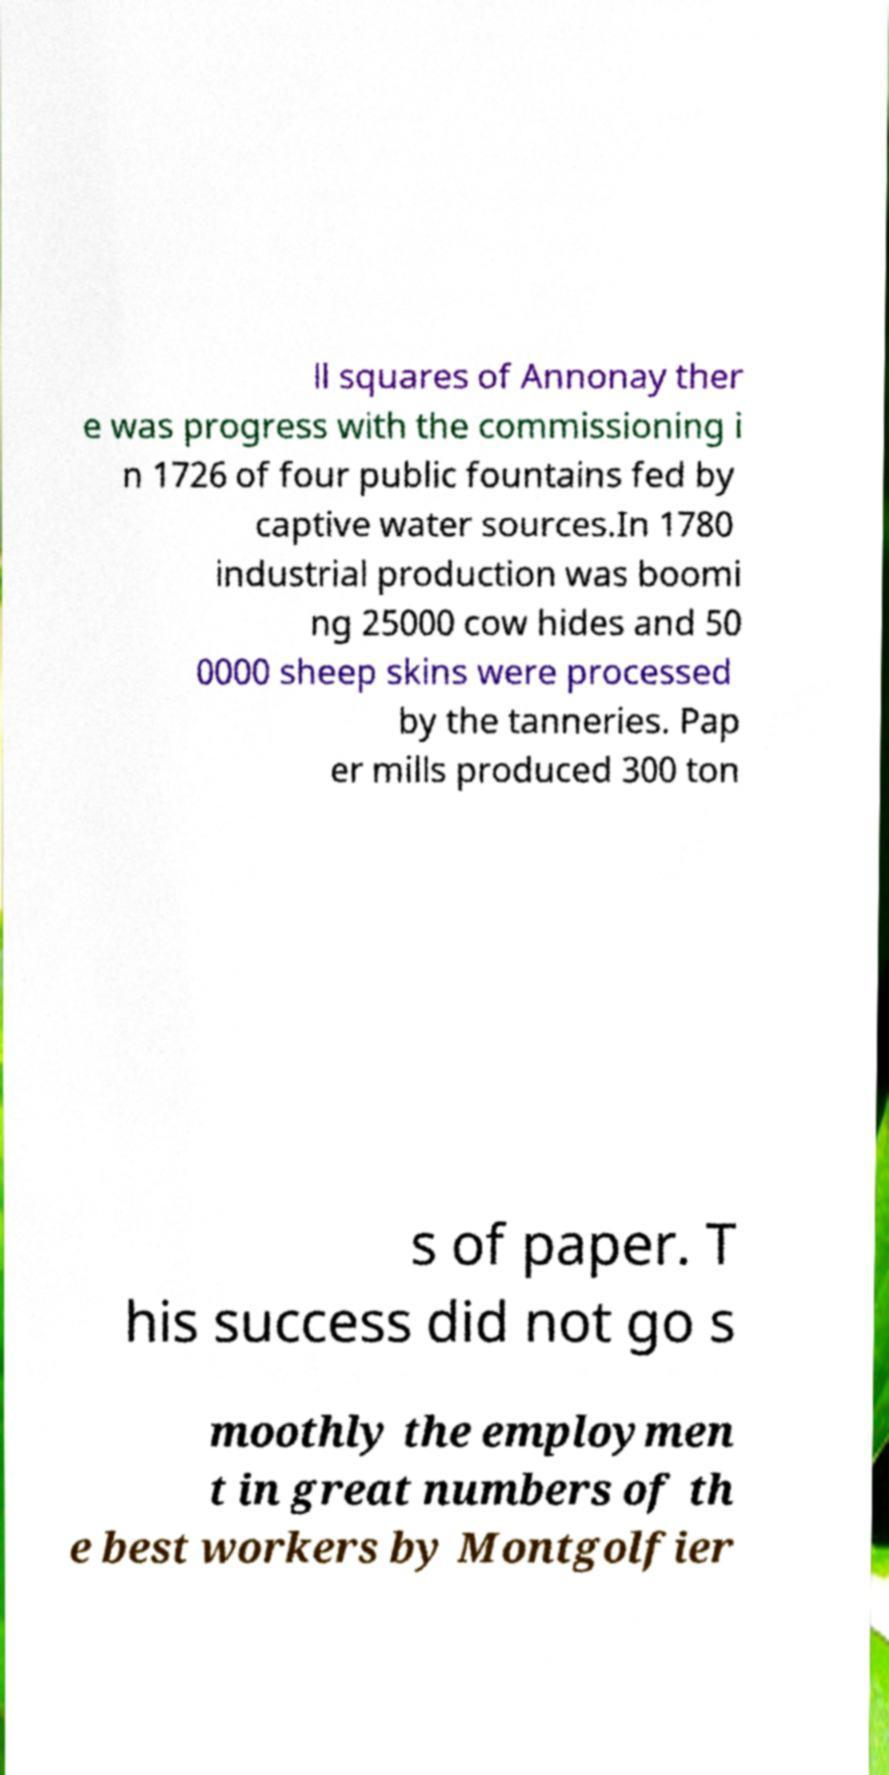Please read and relay the text visible in this image. What does it say? ll squares of Annonay ther e was progress with the commissioning i n 1726 of four public fountains fed by captive water sources.In 1780 industrial production was boomi ng 25000 cow hides and 50 0000 sheep skins were processed by the tanneries. Pap er mills produced 300 ton s of paper. T his success did not go s moothly the employmen t in great numbers of th e best workers by Montgolfier 